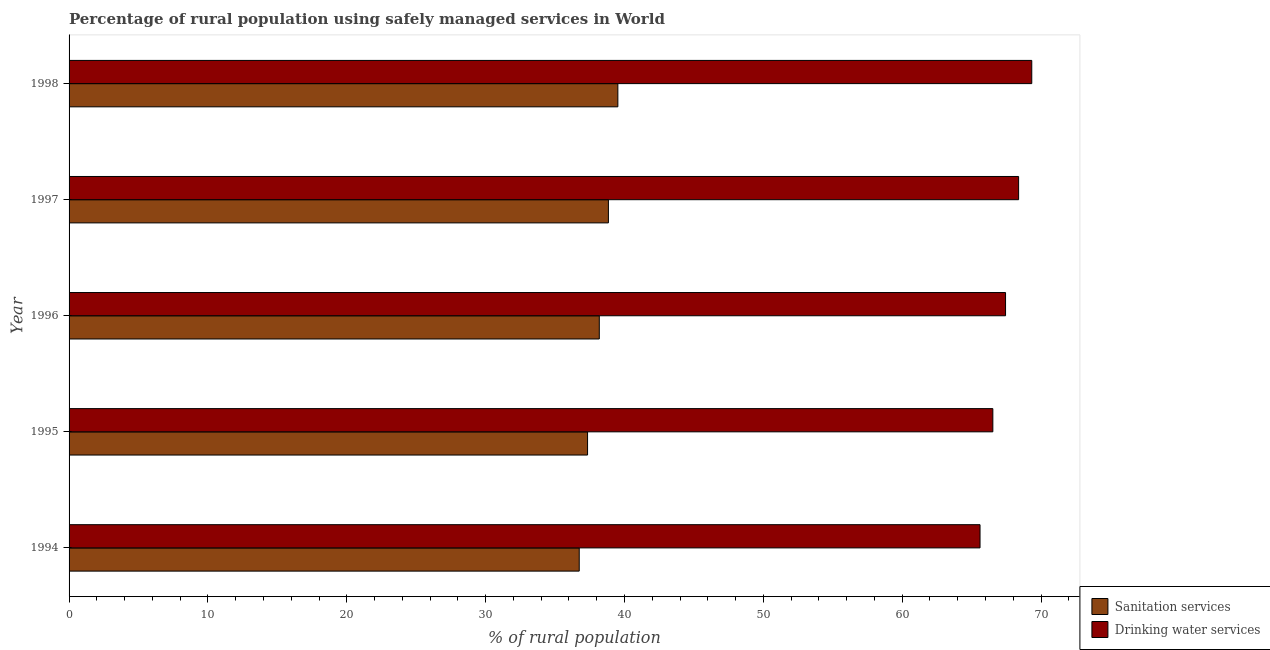How many different coloured bars are there?
Provide a short and direct response. 2. Are the number of bars per tick equal to the number of legend labels?
Your answer should be very brief. Yes. Are the number of bars on each tick of the Y-axis equal?
Provide a succinct answer. Yes. How many bars are there on the 2nd tick from the top?
Offer a very short reply. 2. What is the percentage of rural population who used sanitation services in 1994?
Offer a very short reply. 36.74. Across all years, what is the maximum percentage of rural population who used drinking water services?
Provide a short and direct response. 69.33. Across all years, what is the minimum percentage of rural population who used sanitation services?
Provide a succinct answer. 36.74. What is the total percentage of rural population who used sanitation services in the graph?
Keep it short and to the point. 190.63. What is the difference between the percentage of rural population who used sanitation services in 1995 and that in 1998?
Make the answer very short. -2.18. What is the difference between the percentage of rural population who used drinking water services in 1994 and the percentage of rural population who used sanitation services in 1995?
Your answer should be compact. 28.27. What is the average percentage of rural population who used drinking water services per year?
Ensure brevity in your answer.  67.46. In the year 1996, what is the difference between the percentage of rural population who used drinking water services and percentage of rural population who used sanitation services?
Your answer should be compact. 29.26. What is the ratio of the percentage of rural population who used sanitation services in 1995 to that in 1997?
Offer a terse response. 0.96. What is the difference between the highest and the second highest percentage of rural population who used drinking water services?
Your answer should be compact. 0.95. What is the difference between the highest and the lowest percentage of rural population who used sanitation services?
Your answer should be compact. 2.78. What does the 2nd bar from the top in 1997 represents?
Your answer should be compact. Sanitation services. What does the 1st bar from the bottom in 1996 represents?
Provide a succinct answer. Sanitation services. How many bars are there?
Your answer should be very brief. 10. Are all the bars in the graph horizontal?
Offer a terse response. Yes. Are the values on the major ticks of X-axis written in scientific E-notation?
Provide a succinct answer. No. Does the graph contain any zero values?
Provide a succinct answer. No. Does the graph contain grids?
Offer a terse response. No. Where does the legend appear in the graph?
Provide a short and direct response. Bottom right. How many legend labels are there?
Your answer should be compact. 2. How are the legend labels stacked?
Your answer should be very brief. Vertical. What is the title of the graph?
Give a very brief answer. Percentage of rural population using safely managed services in World. Does "Techinal cooperation" appear as one of the legend labels in the graph?
Your answer should be compact. No. What is the label or title of the X-axis?
Provide a short and direct response. % of rural population. What is the label or title of the Y-axis?
Keep it short and to the point. Year. What is the % of rural population in Sanitation services in 1994?
Make the answer very short. 36.74. What is the % of rural population in Drinking water services in 1994?
Provide a succinct answer. 65.61. What is the % of rural population of Sanitation services in 1995?
Offer a very short reply. 37.34. What is the % of rural population in Drinking water services in 1995?
Provide a short and direct response. 66.53. What is the % of rural population in Sanitation services in 1996?
Ensure brevity in your answer.  38.19. What is the % of rural population in Drinking water services in 1996?
Your response must be concise. 67.44. What is the % of rural population of Sanitation services in 1997?
Provide a short and direct response. 38.84. What is the % of rural population in Drinking water services in 1997?
Keep it short and to the point. 68.38. What is the % of rural population of Sanitation services in 1998?
Keep it short and to the point. 39.52. What is the % of rural population of Drinking water services in 1998?
Give a very brief answer. 69.33. Across all years, what is the maximum % of rural population in Sanitation services?
Provide a short and direct response. 39.52. Across all years, what is the maximum % of rural population in Drinking water services?
Offer a terse response. 69.33. Across all years, what is the minimum % of rural population of Sanitation services?
Provide a short and direct response. 36.74. Across all years, what is the minimum % of rural population in Drinking water services?
Your answer should be compact. 65.61. What is the total % of rural population of Sanitation services in the graph?
Your answer should be very brief. 190.63. What is the total % of rural population in Drinking water services in the graph?
Ensure brevity in your answer.  337.3. What is the difference between the % of rural population of Sanitation services in 1994 and that in 1995?
Ensure brevity in your answer.  -0.6. What is the difference between the % of rural population in Drinking water services in 1994 and that in 1995?
Make the answer very short. -0.92. What is the difference between the % of rural population in Sanitation services in 1994 and that in 1996?
Make the answer very short. -1.45. What is the difference between the % of rural population of Drinking water services in 1994 and that in 1996?
Your answer should be very brief. -1.84. What is the difference between the % of rural population in Sanitation services in 1994 and that in 1997?
Ensure brevity in your answer.  -2.1. What is the difference between the % of rural population in Drinking water services in 1994 and that in 1997?
Ensure brevity in your answer.  -2.78. What is the difference between the % of rural population in Sanitation services in 1994 and that in 1998?
Your answer should be compact. -2.78. What is the difference between the % of rural population in Drinking water services in 1994 and that in 1998?
Give a very brief answer. -3.73. What is the difference between the % of rural population of Sanitation services in 1995 and that in 1996?
Provide a short and direct response. -0.84. What is the difference between the % of rural population in Drinking water services in 1995 and that in 1996?
Make the answer very short. -0.91. What is the difference between the % of rural population of Sanitation services in 1995 and that in 1997?
Your answer should be compact. -1.5. What is the difference between the % of rural population of Drinking water services in 1995 and that in 1997?
Offer a terse response. -1.86. What is the difference between the % of rural population of Sanitation services in 1995 and that in 1998?
Ensure brevity in your answer.  -2.18. What is the difference between the % of rural population of Drinking water services in 1995 and that in 1998?
Your answer should be compact. -2.8. What is the difference between the % of rural population of Sanitation services in 1996 and that in 1997?
Your answer should be very brief. -0.66. What is the difference between the % of rural population of Drinking water services in 1996 and that in 1997?
Your answer should be very brief. -0.94. What is the difference between the % of rural population of Sanitation services in 1996 and that in 1998?
Provide a short and direct response. -1.34. What is the difference between the % of rural population of Drinking water services in 1996 and that in 1998?
Offer a very short reply. -1.89. What is the difference between the % of rural population in Sanitation services in 1997 and that in 1998?
Offer a terse response. -0.68. What is the difference between the % of rural population of Drinking water services in 1997 and that in 1998?
Your answer should be very brief. -0.95. What is the difference between the % of rural population in Sanitation services in 1994 and the % of rural population in Drinking water services in 1995?
Your answer should be very brief. -29.79. What is the difference between the % of rural population in Sanitation services in 1994 and the % of rural population in Drinking water services in 1996?
Ensure brevity in your answer.  -30.7. What is the difference between the % of rural population of Sanitation services in 1994 and the % of rural population of Drinking water services in 1997?
Keep it short and to the point. -31.64. What is the difference between the % of rural population in Sanitation services in 1994 and the % of rural population in Drinking water services in 1998?
Provide a short and direct response. -32.59. What is the difference between the % of rural population in Sanitation services in 1995 and the % of rural population in Drinking water services in 1996?
Make the answer very short. -30.1. What is the difference between the % of rural population in Sanitation services in 1995 and the % of rural population in Drinking water services in 1997?
Your answer should be very brief. -31.04. What is the difference between the % of rural population in Sanitation services in 1995 and the % of rural population in Drinking water services in 1998?
Your answer should be compact. -31.99. What is the difference between the % of rural population in Sanitation services in 1996 and the % of rural population in Drinking water services in 1997?
Give a very brief answer. -30.2. What is the difference between the % of rural population of Sanitation services in 1996 and the % of rural population of Drinking water services in 1998?
Ensure brevity in your answer.  -31.15. What is the difference between the % of rural population of Sanitation services in 1997 and the % of rural population of Drinking water services in 1998?
Give a very brief answer. -30.49. What is the average % of rural population of Sanitation services per year?
Your response must be concise. 38.13. What is the average % of rural population of Drinking water services per year?
Provide a succinct answer. 67.46. In the year 1994, what is the difference between the % of rural population in Sanitation services and % of rural population in Drinking water services?
Provide a succinct answer. -28.87. In the year 1995, what is the difference between the % of rural population of Sanitation services and % of rural population of Drinking water services?
Your response must be concise. -29.19. In the year 1996, what is the difference between the % of rural population of Sanitation services and % of rural population of Drinking water services?
Provide a succinct answer. -29.26. In the year 1997, what is the difference between the % of rural population in Sanitation services and % of rural population in Drinking water services?
Your answer should be very brief. -29.54. In the year 1998, what is the difference between the % of rural population of Sanitation services and % of rural population of Drinking water services?
Your answer should be very brief. -29.81. What is the ratio of the % of rural population of Sanitation services in 1994 to that in 1995?
Offer a very short reply. 0.98. What is the ratio of the % of rural population of Drinking water services in 1994 to that in 1995?
Ensure brevity in your answer.  0.99. What is the ratio of the % of rural population of Sanitation services in 1994 to that in 1996?
Ensure brevity in your answer.  0.96. What is the ratio of the % of rural population in Drinking water services in 1994 to that in 1996?
Provide a short and direct response. 0.97. What is the ratio of the % of rural population of Sanitation services in 1994 to that in 1997?
Offer a very short reply. 0.95. What is the ratio of the % of rural population in Drinking water services in 1994 to that in 1997?
Your answer should be very brief. 0.96. What is the ratio of the % of rural population in Sanitation services in 1994 to that in 1998?
Make the answer very short. 0.93. What is the ratio of the % of rural population of Drinking water services in 1994 to that in 1998?
Offer a terse response. 0.95. What is the ratio of the % of rural population of Sanitation services in 1995 to that in 1996?
Keep it short and to the point. 0.98. What is the ratio of the % of rural population in Drinking water services in 1995 to that in 1996?
Your answer should be very brief. 0.99. What is the ratio of the % of rural population of Sanitation services in 1995 to that in 1997?
Provide a succinct answer. 0.96. What is the ratio of the % of rural population of Drinking water services in 1995 to that in 1997?
Your answer should be very brief. 0.97. What is the ratio of the % of rural population of Sanitation services in 1995 to that in 1998?
Provide a succinct answer. 0.94. What is the ratio of the % of rural population of Drinking water services in 1995 to that in 1998?
Your answer should be compact. 0.96. What is the ratio of the % of rural population of Sanitation services in 1996 to that in 1997?
Offer a very short reply. 0.98. What is the ratio of the % of rural population of Drinking water services in 1996 to that in 1997?
Your answer should be compact. 0.99. What is the ratio of the % of rural population of Sanitation services in 1996 to that in 1998?
Your answer should be very brief. 0.97. What is the ratio of the % of rural population of Drinking water services in 1996 to that in 1998?
Keep it short and to the point. 0.97. What is the ratio of the % of rural population in Sanitation services in 1997 to that in 1998?
Provide a short and direct response. 0.98. What is the ratio of the % of rural population of Drinking water services in 1997 to that in 1998?
Provide a succinct answer. 0.99. What is the difference between the highest and the second highest % of rural population of Sanitation services?
Provide a short and direct response. 0.68. What is the difference between the highest and the second highest % of rural population of Drinking water services?
Keep it short and to the point. 0.95. What is the difference between the highest and the lowest % of rural population in Sanitation services?
Provide a succinct answer. 2.78. What is the difference between the highest and the lowest % of rural population in Drinking water services?
Keep it short and to the point. 3.73. 